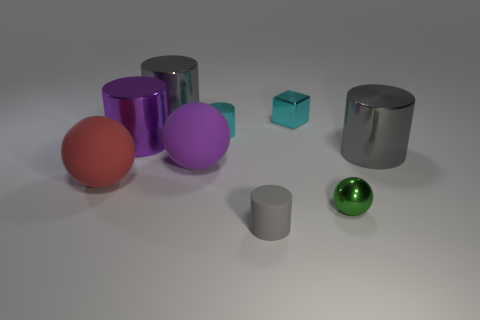How many gray cylinders must be subtracted to get 1 gray cylinders? 2 Add 6 tiny metal balls. How many tiny metal balls exist? 7 Subtract all cyan cylinders. How many cylinders are left? 4 Subtract all rubber balls. How many balls are left? 1 Subtract 1 purple balls. How many objects are left? 8 Subtract all spheres. How many objects are left? 6 Subtract 1 cylinders. How many cylinders are left? 4 Subtract all blue cubes. Subtract all gray cylinders. How many cubes are left? 1 Subtract all cyan blocks. How many gray cylinders are left? 3 Subtract all small yellow rubber cylinders. Subtract all blocks. How many objects are left? 8 